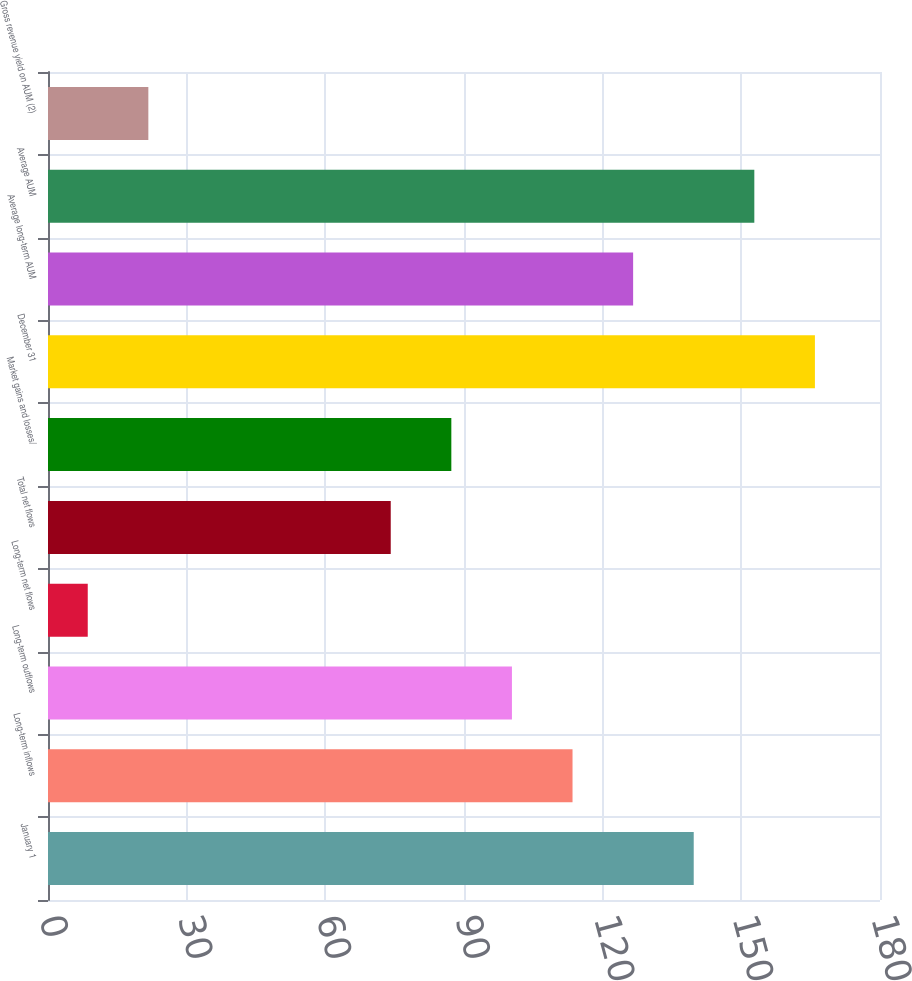Convert chart to OTSL. <chart><loc_0><loc_0><loc_500><loc_500><bar_chart><fcel>January 1<fcel>Long-term inflows<fcel>Long-term outflows<fcel>Long-term net flows<fcel>Total net flows<fcel>Market gains and losses/<fcel>December 31<fcel>Average long-term AUM<fcel>Average AUM<fcel>Gross revenue yield on AUM (2)<nl><fcel>139.7<fcel>113.48<fcel>100.37<fcel>8.6<fcel>74.15<fcel>87.26<fcel>165.92<fcel>126.59<fcel>152.81<fcel>21.71<nl></chart> 